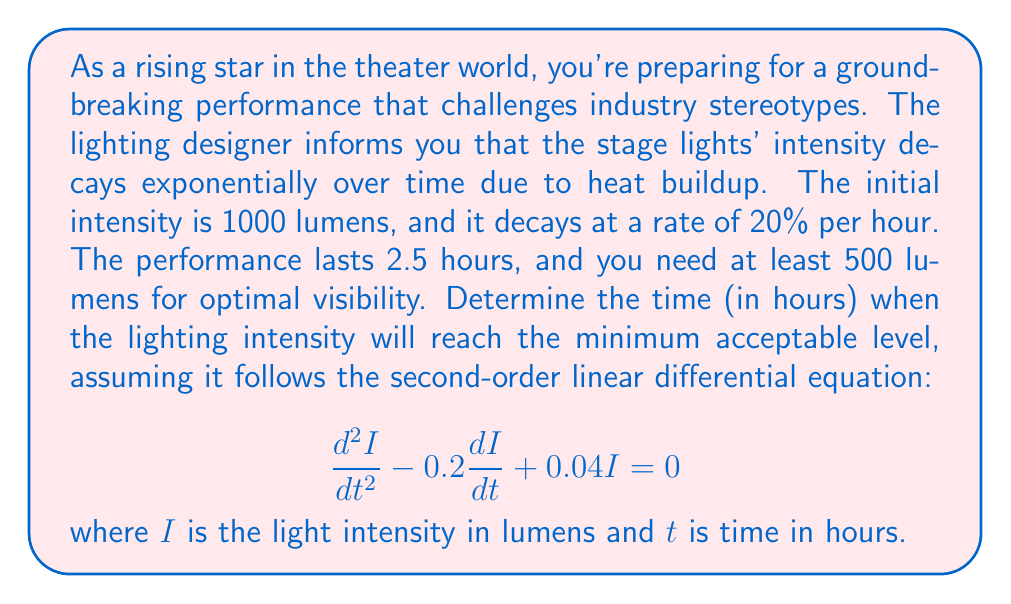Show me your answer to this math problem. Let's approach this step-by-step:

1) The general solution for this second-order linear differential equation is:

   $$I(t) = C_1e^{r_1t} + C_2e^{r_2t}$$

   where $r_1$ and $r_2$ are roots of the characteristic equation.

2) The characteristic equation is:
   
   $$r^2 - 0.2r + 0.04 = 0$$

3) Solving this quadratic equation:

   $$r = \frac{0.2 \pm \sqrt{0.04 - 4(0.04)}}{2} = 0.1 \pm 0.1$$

   So, $r_1 = 0.2$ and $r_2 = 0$

4) Therefore, the general solution is:

   $$I(t) = C_1e^{0.2t} + C_2$$

5) Given the initial condition $I(0) = 1000$ and the decay rate of 20% per hour, we can write:

   $$I(t) = 1000e^{-0.2t}$$

6) To find when this reaches 500 lumens, we solve:

   $$500 = 1000e^{-0.2t}$$

7) Taking natural log of both sides:

   $$\ln(0.5) = -0.2t$$

8) Solving for $t$:

   $$t = \frac{-\ln(0.5)}{0.2} \approx 3.47\text{ hours}$$
Answer: The lighting intensity will reach the minimum acceptable level of 500 lumens after approximately 3.47 hours. 